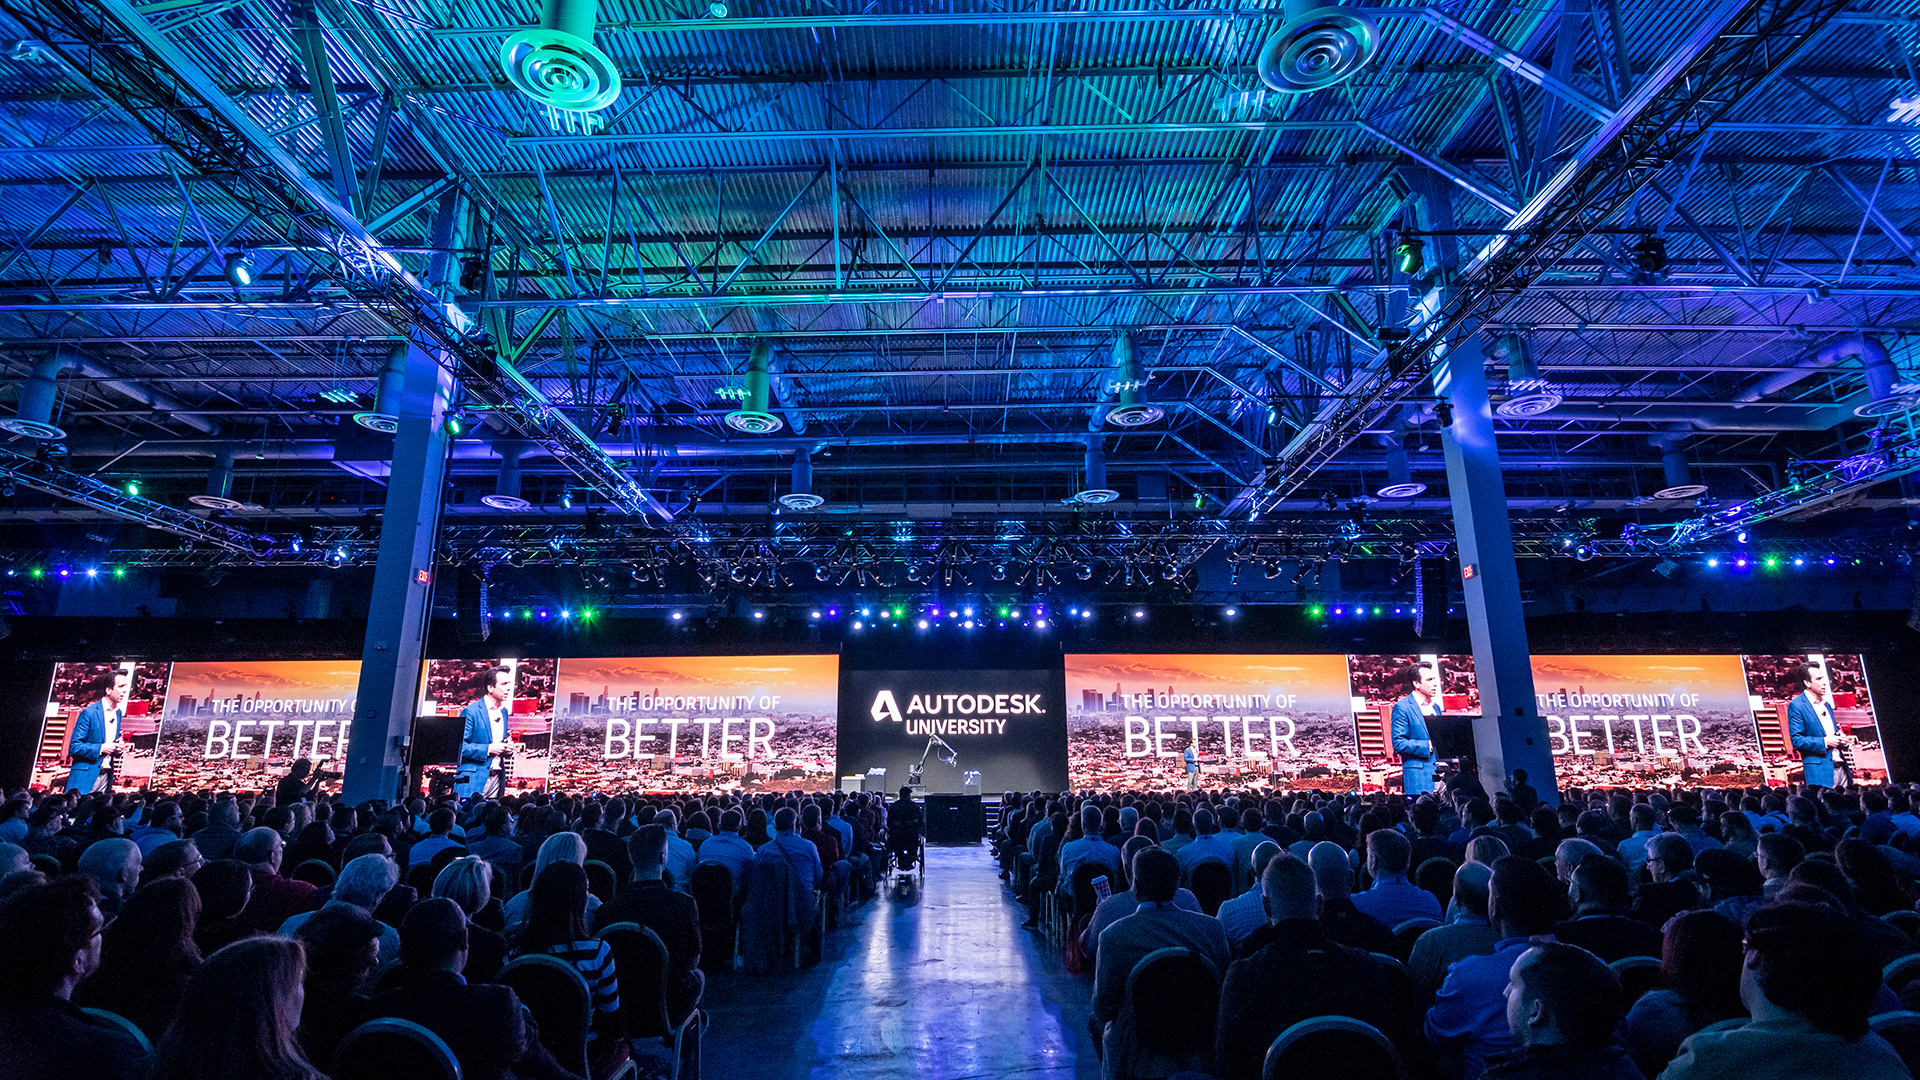Imagine a future scenario where this event is taking place on Mars. How would the setting and activities differ? In a futuristic scenario where Autodesk University is held on Mars, the setting would be dramatically different, featuring Martian landscapes visible through large, domed windows of a high-tech conference center. The gravity would be lower, possibly influencing the design of the venue and the way activities are conducted. Sessions might include discussions on designing sustainable habitats for Mars, innovative construction techniques using Martian soil, and advancements in 3D printing technology for building on the Red Planet. Interactive activities could utilize virtual reality to simulate life on Mars, and hands-on workshops might involve creating prototypes of Martian vehicles or exploration tools. Networking events would likely focus on cross-planetary collaboration, connecting professionals working both on Mars and Earth in real-time through advanced holographic communication technologies. 